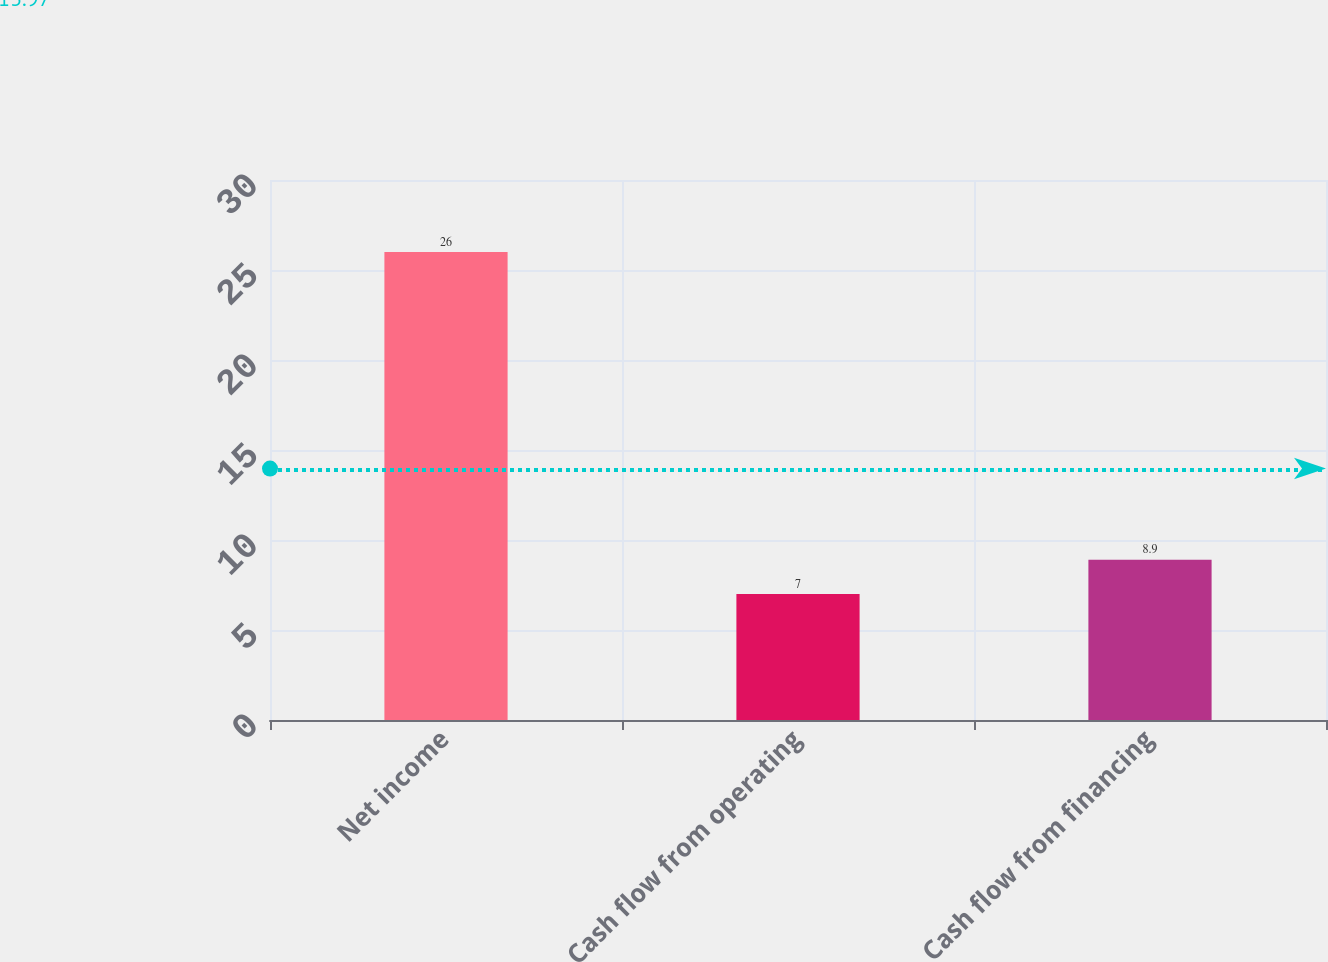Convert chart. <chart><loc_0><loc_0><loc_500><loc_500><bar_chart><fcel>Net income<fcel>Cash flow from operating<fcel>Cash flow from financing<nl><fcel>26<fcel>7<fcel>8.9<nl></chart> 